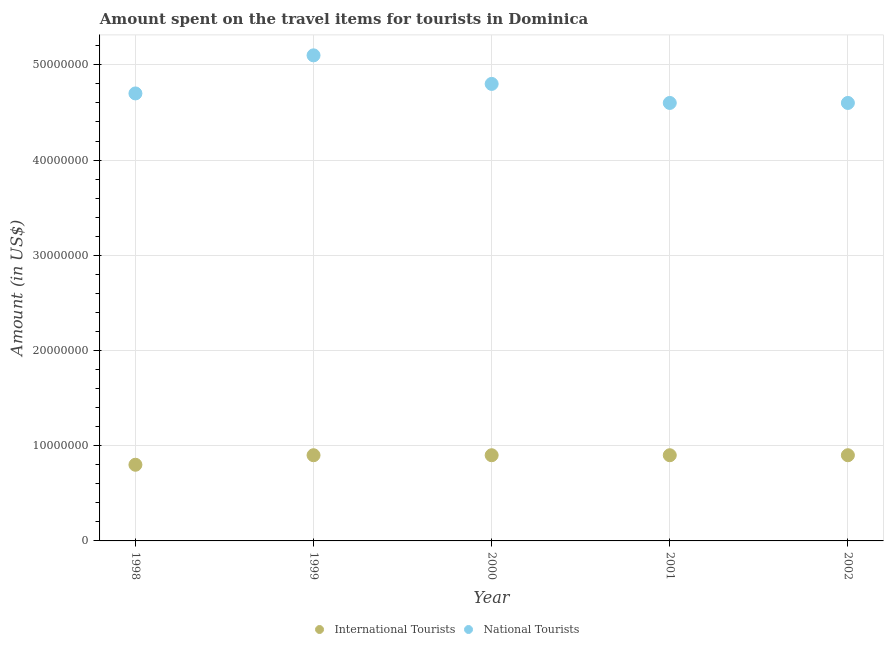How many different coloured dotlines are there?
Your answer should be compact. 2. What is the amount spent on travel items of international tourists in 1998?
Keep it short and to the point. 8.00e+06. Across all years, what is the maximum amount spent on travel items of international tourists?
Offer a terse response. 9.00e+06. Across all years, what is the minimum amount spent on travel items of international tourists?
Provide a short and direct response. 8.00e+06. In which year was the amount spent on travel items of international tourists minimum?
Your response must be concise. 1998. What is the total amount spent on travel items of international tourists in the graph?
Keep it short and to the point. 4.40e+07. What is the difference between the amount spent on travel items of international tourists in 1998 and that in 2002?
Make the answer very short. -1.00e+06. What is the difference between the amount spent on travel items of national tourists in 2001 and the amount spent on travel items of international tourists in 1999?
Ensure brevity in your answer.  3.70e+07. What is the average amount spent on travel items of national tourists per year?
Give a very brief answer. 4.76e+07. In the year 1999, what is the difference between the amount spent on travel items of national tourists and amount spent on travel items of international tourists?
Offer a terse response. 4.20e+07. What is the difference between the highest and the second highest amount spent on travel items of international tourists?
Your response must be concise. 0. What is the difference between the highest and the lowest amount spent on travel items of national tourists?
Give a very brief answer. 5.00e+06. Is the sum of the amount spent on travel items of international tourists in 2000 and 2002 greater than the maximum amount spent on travel items of national tourists across all years?
Make the answer very short. No. Does the amount spent on travel items of national tourists monotonically increase over the years?
Keep it short and to the point. No. Where does the legend appear in the graph?
Your answer should be very brief. Bottom center. How many legend labels are there?
Keep it short and to the point. 2. How are the legend labels stacked?
Ensure brevity in your answer.  Horizontal. What is the title of the graph?
Make the answer very short. Amount spent on the travel items for tourists in Dominica. Does "Male labourers" appear as one of the legend labels in the graph?
Your answer should be very brief. No. What is the label or title of the Y-axis?
Give a very brief answer. Amount (in US$). What is the Amount (in US$) of International Tourists in 1998?
Offer a terse response. 8.00e+06. What is the Amount (in US$) in National Tourists in 1998?
Ensure brevity in your answer.  4.70e+07. What is the Amount (in US$) of International Tourists in 1999?
Offer a very short reply. 9.00e+06. What is the Amount (in US$) of National Tourists in 1999?
Provide a succinct answer. 5.10e+07. What is the Amount (in US$) of International Tourists in 2000?
Offer a very short reply. 9.00e+06. What is the Amount (in US$) in National Tourists in 2000?
Your answer should be very brief. 4.80e+07. What is the Amount (in US$) of International Tourists in 2001?
Give a very brief answer. 9.00e+06. What is the Amount (in US$) in National Tourists in 2001?
Provide a succinct answer. 4.60e+07. What is the Amount (in US$) of International Tourists in 2002?
Keep it short and to the point. 9.00e+06. What is the Amount (in US$) in National Tourists in 2002?
Offer a very short reply. 4.60e+07. Across all years, what is the maximum Amount (in US$) of International Tourists?
Give a very brief answer. 9.00e+06. Across all years, what is the maximum Amount (in US$) of National Tourists?
Provide a succinct answer. 5.10e+07. Across all years, what is the minimum Amount (in US$) of International Tourists?
Give a very brief answer. 8.00e+06. Across all years, what is the minimum Amount (in US$) of National Tourists?
Offer a terse response. 4.60e+07. What is the total Amount (in US$) in International Tourists in the graph?
Offer a terse response. 4.40e+07. What is the total Amount (in US$) of National Tourists in the graph?
Your response must be concise. 2.38e+08. What is the difference between the Amount (in US$) in National Tourists in 1998 and that in 2000?
Make the answer very short. -1.00e+06. What is the difference between the Amount (in US$) of International Tourists in 1998 and that in 2002?
Give a very brief answer. -1.00e+06. What is the difference between the Amount (in US$) in National Tourists in 1998 and that in 2002?
Your answer should be very brief. 1.00e+06. What is the difference between the Amount (in US$) in National Tourists in 1999 and that in 2000?
Offer a terse response. 3.00e+06. What is the difference between the Amount (in US$) of International Tourists in 1999 and that in 2001?
Keep it short and to the point. 0. What is the difference between the Amount (in US$) in National Tourists in 1999 and that in 2001?
Your answer should be very brief. 5.00e+06. What is the difference between the Amount (in US$) of International Tourists in 1999 and that in 2002?
Provide a succinct answer. 0. What is the difference between the Amount (in US$) of International Tourists in 2000 and that in 2001?
Your answer should be very brief. 0. What is the difference between the Amount (in US$) in National Tourists in 2000 and that in 2002?
Provide a short and direct response. 2.00e+06. What is the difference between the Amount (in US$) of International Tourists in 1998 and the Amount (in US$) of National Tourists in 1999?
Provide a short and direct response. -4.30e+07. What is the difference between the Amount (in US$) of International Tourists in 1998 and the Amount (in US$) of National Tourists in 2000?
Give a very brief answer. -4.00e+07. What is the difference between the Amount (in US$) of International Tourists in 1998 and the Amount (in US$) of National Tourists in 2001?
Keep it short and to the point. -3.80e+07. What is the difference between the Amount (in US$) of International Tourists in 1998 and the Amount (in US$) of National Tourists in 2002?
Your response must be concise. -3.80e+07. What is the difference between the Amount (in US$) in International Tourists in 1999 and the Amount (in US$) in National Tourists in 2000?
Ensure brevity in your answer.  -3.90e+07. What is the difference between the Amount (in US$) of International Tourists in 1999 and the Amount (in US$) of National Tourists in 2001?
Offer a terse response. -3.70e+07. What is the difference between the Amount (in US$) of International Tourists in 1999 and the Amount (in US$) of National Tourists in 2002?
Your response must be concise. -3.70e+07. What is the difference between the Amount (in US$) of International Tourists in 2000 and the Amount (in US$) of National Tourists in 2001?
Give a very brief answer. -3.70e+07. What is the difference between the Amount (in US$) of International Tourists in 2000 and the Amount (in US$) of National Tourists in 2002?
Offer a very short reply. -3.70e+07. What is the difference between the Amount (in US$) of International Tourists in 2001 and the Amount (in US$) of National Tourists in 2002?
Keep it short and to the point. -3.70e+07. What is the average Amount (in US$) of International Tourists per year?
Your response must be concise. 8.80e+06. What is the average Amount (in US$) in National Tourists per year?
Your response must be concise. 4.76e+07. In the year 1998, what is the difference between the Amount (in US$) in International Tourists and Amount (in US$) in National Tourists?
Your answer should be compact. -3.90e+07. In the year 1999, what is the difference between the Amount (in US$) in International Tourists and Amount (in US$) in National Tourists?
Your answer should be very brief. -4.20e+07. In the year 2000, what is the difference between the Amount (in US$) of International Tourists and Amount (in US$) of National Tourists?
Your answer should be compact. -3.90e+07. In the year 2001, what is the difference between the Amount (in US$) of International Tourists and Amount (in US$) of National Tourists?
Make the answer very short. -3.70e+07. In the year 2002, what is the difference between the Amount (in US$) in International Tourists and Amount (in US$) in National Tourists?
Your answer should be very brief. -3.70e+07. What is the ratio of the Amount (in US$) of National Tourists in 1998 to that in 1999?
Keep it short and to the point. 0.92. What is the ratio of the Amount (in US$) of International Tourists in 1998 to that in 2000?
Your answer should be compact. 0.89. What is the ratio of the Amount (in US$) in National Tourists in 1998 to that in 2000?
Your answer should be very brief. 0.98. What is the ratio of the Amount (in US$) in National Tourists in 1998 to that in 2001?
Keep it short and to the point. 1.02. What is the ratio of the Amount (in US$) in National Tourists in 1998 to that in 2002?
Make the answer very short. 1.02. What is the ratio of the Amount (in US$) in National Tourists in 1999 to that in 2000?
Offer a terse response. 1.06. What is the ratio of the Amount (in US$) of National Tourists in 1999 to that in 2001?
Your answer should be very brief. 1.11. What is the ratio of the Amount (in US$) in National Tourists in 1999 to that in 2002?
Provide a succinct answer. 1.11. What is the ratio of the Amount (in US$) in International Tourists in 2000 to that in 2001?
Offer a terse response. 1. What is the ratio of the Amount (in US$) in National Tourists in 2000 to that in 2001?
Your answer should be compact. 1.04. What is the ratio of the Amount (in US$) in National Tourists in 2000 to that in 2002?
Offer a very short reply. 1.04. What is the ratio of the Amount (in US$) of International Tourists in 2001 to that in 2002?
Your answer should be compact. 1. What is the difference between the highest and the second highest Amount (in US$) of International Tourists?
Your answer should be very brief. 0. What is the difference between the highest and the second highest Amount (in US$) of National Tourists?
Make the answer very short. 3.00e+06. 